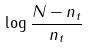Convert formula to latex. <formula><loc_0><loc_0><loc_500><loc_500>\log \frac { N - n _ { t } } { n _ { t } }</formula> 